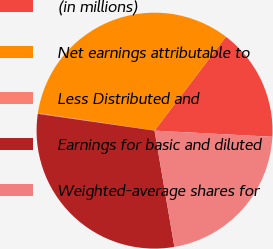Convert chart. <chart><loc_0><loc_0><loc_500><loc_500><pie_chart><fcel>(in millions)<fcel>Net earnings attributable to<fcel>Less Distributed and<fcel>Earnings for basic and diluted<fcel>Weighted-average shares for<nl><fcel>15.48%<fcel>32.96%<fcel>0.12%<fcel>29.96%<fcel>21.48%<nl></chart> 